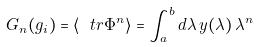Convert formula to latex. <formula><loc_0><loc_0><loc_500><loc_500>G _ { n } ( g _ { i } ) = \langle \ t r \Phi ^ { n } \rangle = \int _ { a } ^ { b } d \lambda \, y ( \lambda ) \, \lambda ^ { n }</formula> 